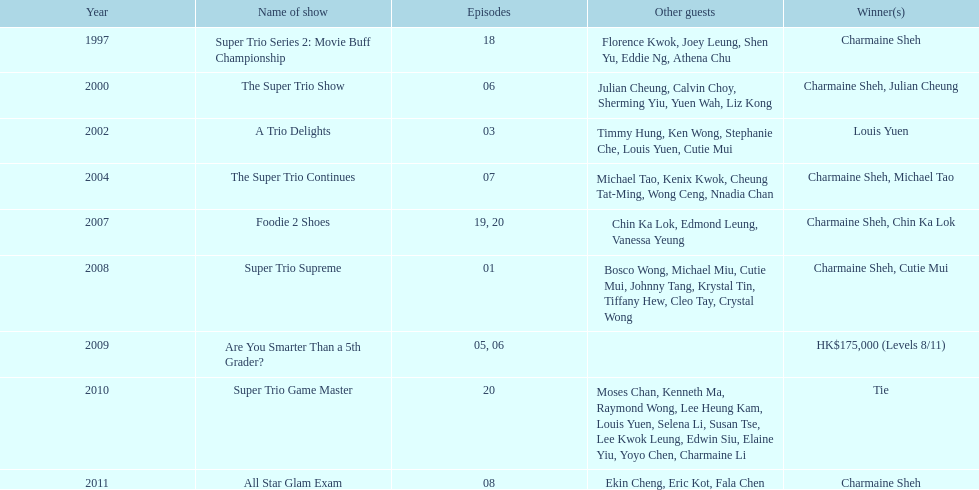In how many television series has charmaine sheh made appearances? 9. 